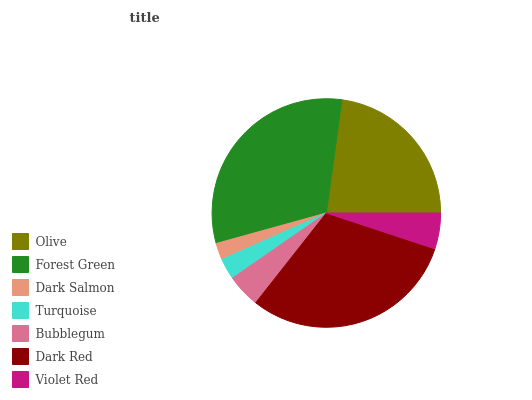Is Dark Salmon the minimum?
Answer yes or no. Yes. Is Forest Green the maximum?
Answer yes or no. Yes. Is Forest Green the minimum?
Answer yes or no. No. Is Dark Salmon the maximum?
Answer yes or no. No. Is Forest Green greater than Dark Salmon?
Answer yes or no. Yes. Is Dark Salmon less than Forest Green?
Answer yes or no. Yes. Is Dark Salmon greater than Forest Green?
Answer yes or no. No. Is Forest Green less than Dark Salmon?
Answer yes or no. No. Is Violet Red the high median?
Answer yes or no. Yes. Is Violet Red the low median?
Answer yes or no. Yes. Is Olive the high median?
Answer yes or no. No. Is Turquoise the low median?
Answer yes or no. No. 